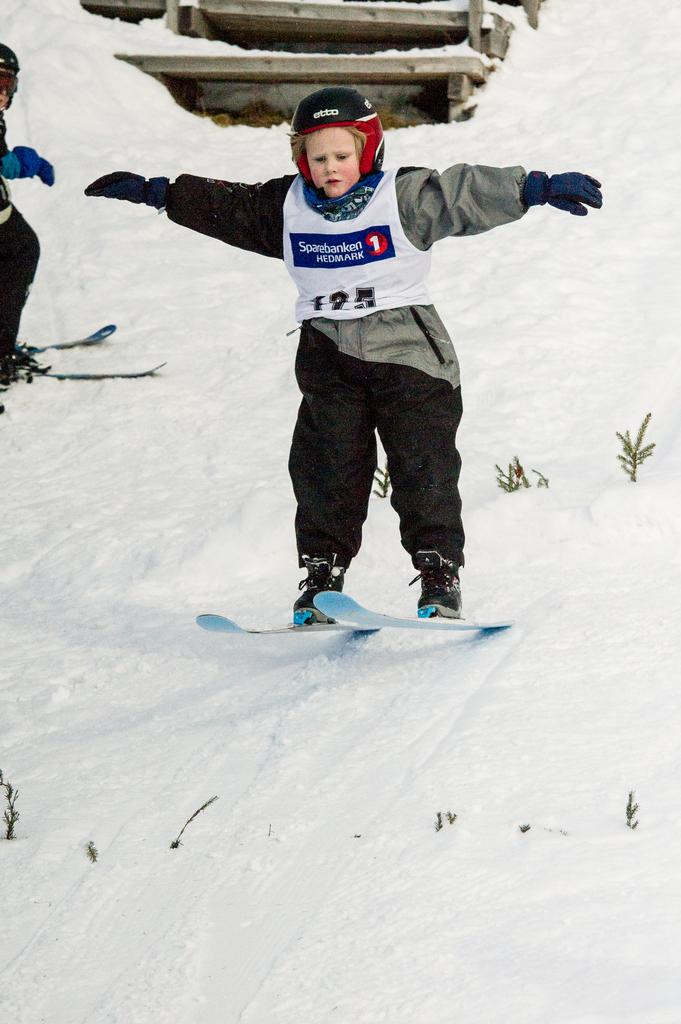Who is the main subject in the image? There is a boy in the center of the image. What is the boy doing in the image? The boy is on ski boards. What is the setting of the image? There is snow visible in the image. Are there any other people in the image? Yes, there is a person on the left side of the image. What is the person on the left side doing? The person on the left side is also on ski boards. How many beds are visible in the image? There are no beds visible in the image. What type of locket is the boy wearing in the image? There is no locket present in the image. 